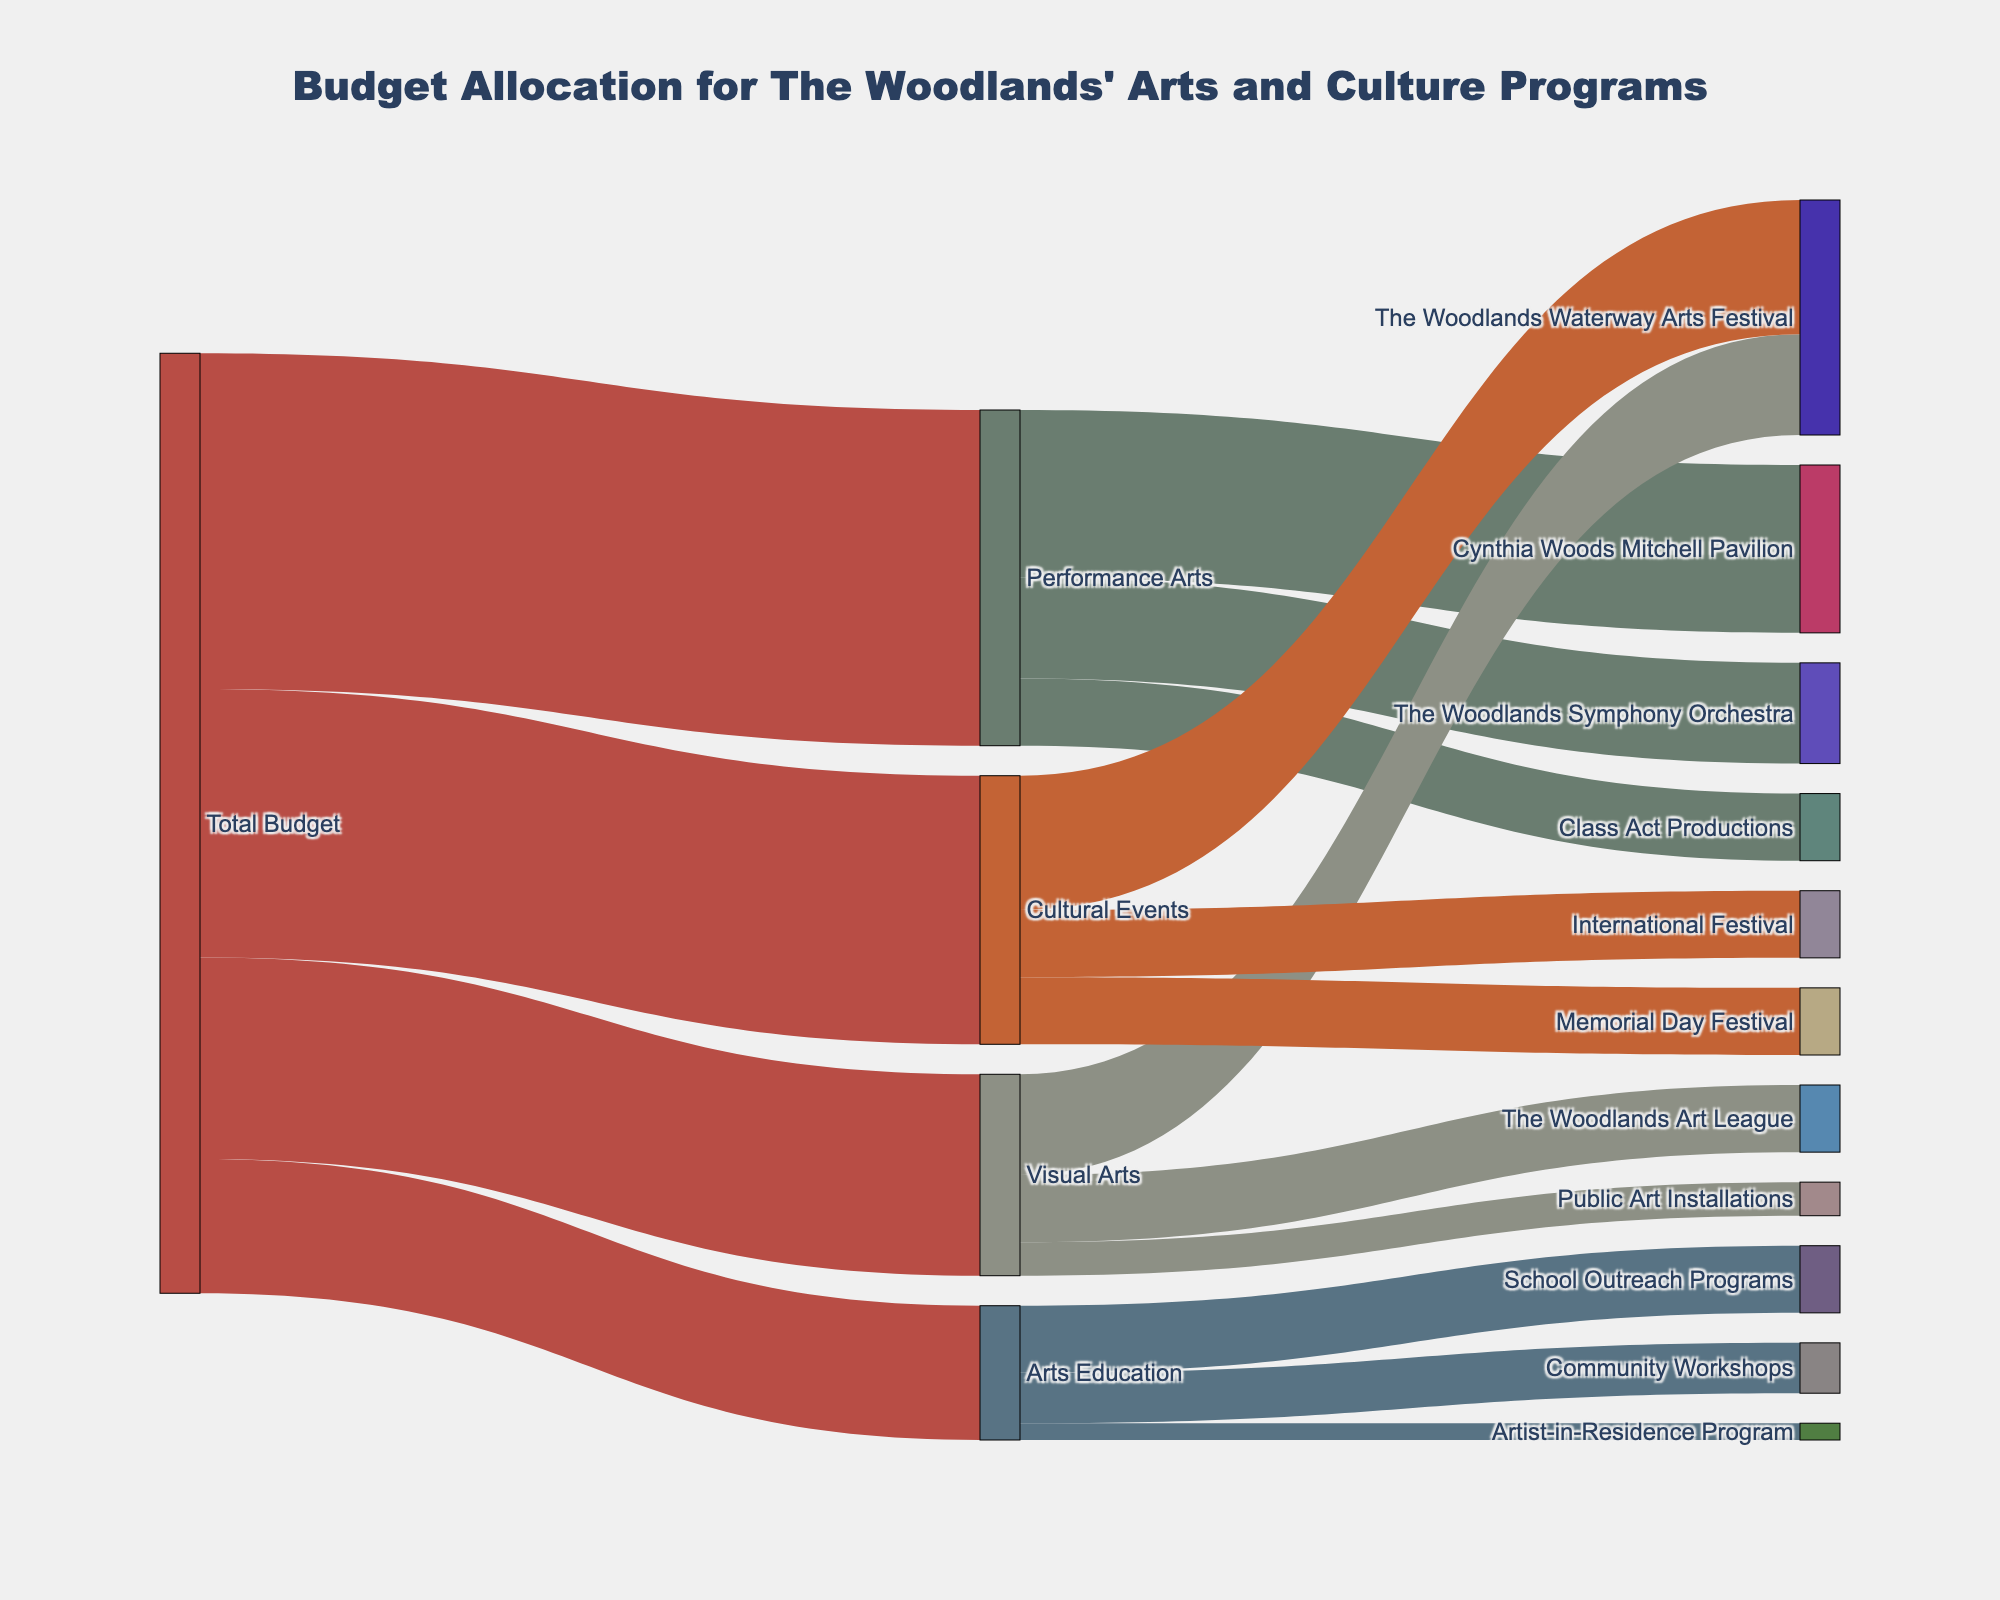what is the total budget allocated for arts and culture programs in The Woodlands? The title of the Sankey Diagram mentions it represents the budget allocation for The Woodlands' arts and culture programs. The diagram shows the 'Total Budget' flowing to various categories. The value connected from the 'Total Budget' node is the sum of all initial allocations: 500,000 + 300,000 + 400,000 + 200,000 = 1,400,000
Answer: 1,400,000 How much budget is allocated to the Cynthia Woods Mitchell Pavilion? Within the 'Performance Arts' category, there is one node flowing to 'Cynthia Woods Mitchell Pavilion' with a value label on the Sankey Diagram.
Answer: 250,000 What is the difference between the budget allocated to Cultural Events and Arts Education? The figure shows the budget values for Cultural Events, which is 400,000, and for Arts Education, which is 200,000. Subtracting the budget for Arts Education from Cultural Events gives: 400,000 - 200,000 = 200,000
Answer: 200,000 Which three specific groups receive fundings under Visual Arts and what are their respective amounts? In the 'Visual Arts' category, the diagram shows three groups with values: The Woodlands Waterway Arts Festival (150,000), The Woodlands Art League (100,000), and Public Art Installations (50,000)
Answer: The Woodlands Waterway Arts Festival: 150,000, The Woodlands Art League: 100,000, Public Art Installations: 50,000 Which category receives the highest budget allocation, and what is its code? By comparing the values from the 'Total Budget' node flowing to Performance Arts (500,000), Visual Arts (300,000), Cultural Events (400,000), and Arts Education (200,000), the highest allocation is for Performance Arts
Answer: Performance Arts, 500000 What is the breakdown of funding within the Performance Arts category? The Performance Arts box splits its budget into three segments feeding into: Cynthia Woods Mitchell Pavilion (250,000), The Woodlands Symphony Orchestra (150,000), and Class Act Productions (100,000)
Answer: Cynthia Woods Mitchell Pavilion: 250,000, The Woodlands Symphony Orchestra: 150,000, Class Act Productions: 100,000 Which event under Cultural Events has the smallest funding, and how much is it? Referring to the lines under the 'Cultural Events' category, three events get funding: The Woodlands Waterway Arts Festival (200,000), Memorial Day Festival (100,000), and International Festival (100,000). The smallest funding is for Memorial Day Festival and International Festival, both receiving 100,000 each.
Answer: Memorial Day Festival and International Festival: 100,000 each How does the funding for School Outreach Programs compare to that for Community Workshops? Within the 'Arts Education' category, School Outreach Programs receives 100,000, while Community Workshops receives 75,000. School Outreach Programs receive more funding by 25,000.
Answer: School Outreach Programs: 100,000, Community Workshops: 75,000 What are the nodes in the diagram labeled that receive funding directly from 'Total Budget'? The main nodes stemming from 'Total Budget' are Performance Arts, Visual Arts, Cultural Events, and Arts Education.
Answer: Performance Arts, Visual Arts, Cultural Events, Arts Education 